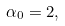<formula> <loc_0><loc_0><loc_500><loc_500>\alpha _ { 0 } = 2 ,</formula> 